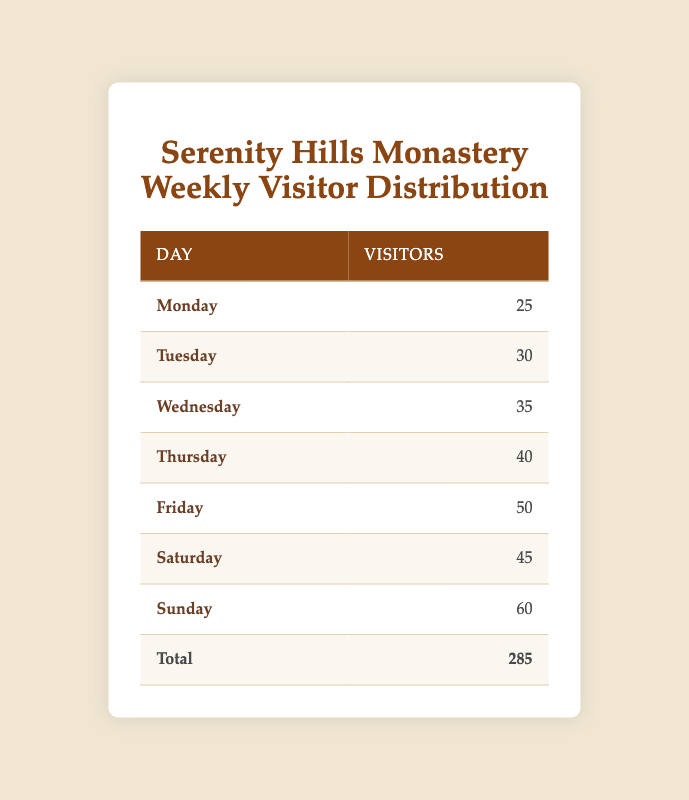What is the highest number of visitors on a single day? By examining the counts of visitors for each day, Sunday has the highest count, which is 60 visitors.
Answer: 60 Which day had the least number of visitors? Looking at the table, Monday has the least count of visitors, which is 25.
Answer: 25 What is the total number of visitors over the week? The total number of visitors can be calculated by summing the counts for each day: 25 + 30 + 35 + 40 + 50 + 45 + 60 = 285.
Answer: 285 Is it true that there were more visitors on Saturday than on Thursday? By checking the counts, Saturday had 45 visitors and Thursday had 40 visitors. Since 45 is greater than 40, the statement is true.
Answer: Yes What is the average number of visitors per day? To calculate the average, sum the total number of visitors (285) and divide by the number of days (7): 285 / 7 = 40.71, which can be rounded to 41 when considering whole visitors.
Answer: 41 How many more visitors were there on Friday compared to Monday? Friday had 50 visitors, and Monday had 25 visitors. The difference is 50 - 25 = 25 visitors more on Friday.
Answer: 25 On which day(s) did the monastery receive more than 40 visitors? Reviewing the table, the days with more than 40 visitors are Thursday (40), Friday (50), Saturday (45), and Sunday (60). Therefore, there are four days that meet this condition.
Answer: Four days What percentage of the total weekly visitors came on Sunday? To find the percentage of visitors on Sunday (60) out of the total (285), use the formula (60 / 285) * 100, which equals approximately 21.05%.
Answer: 21.05% 